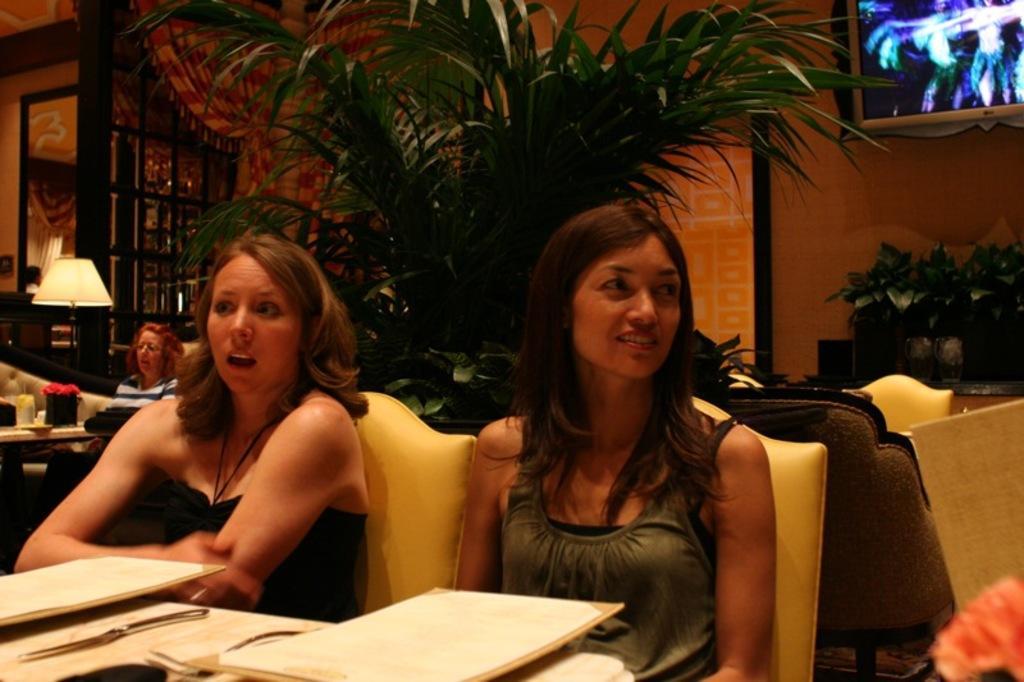Please provide a concise description of this image. There are two ladies are sitting on chairs. In front of them there is a table. On the table there is a sheath and knife. Besides them there is a plant, television, table lamp, door. 